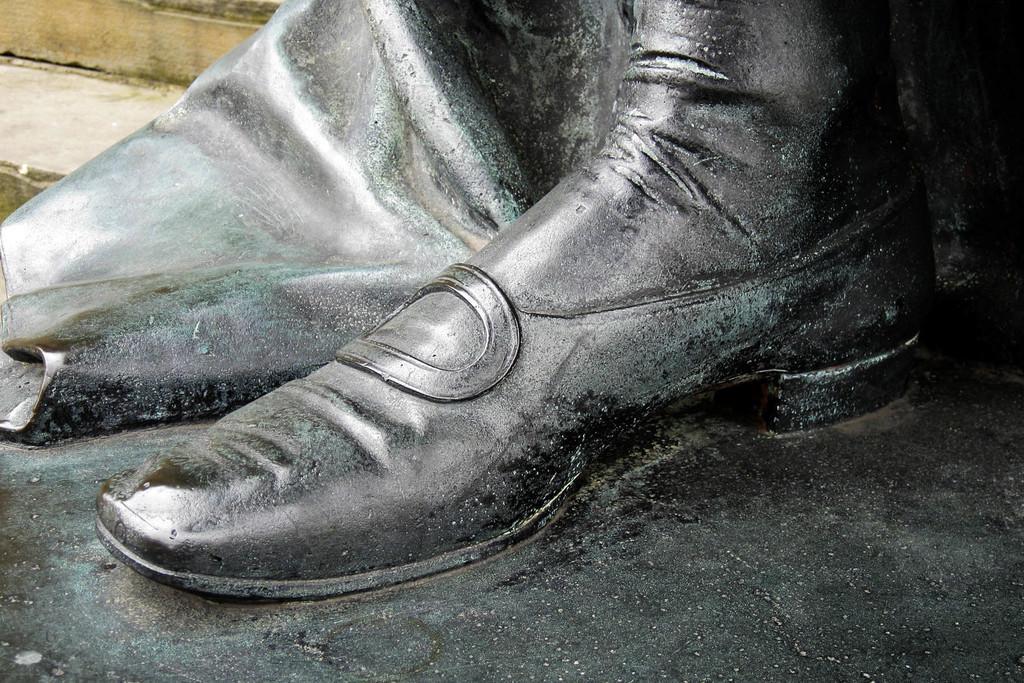Describe this image in one or two sentences. In this image, I can see a leg of a statue. At the top left corner of the image, these are looking like the stairs. 